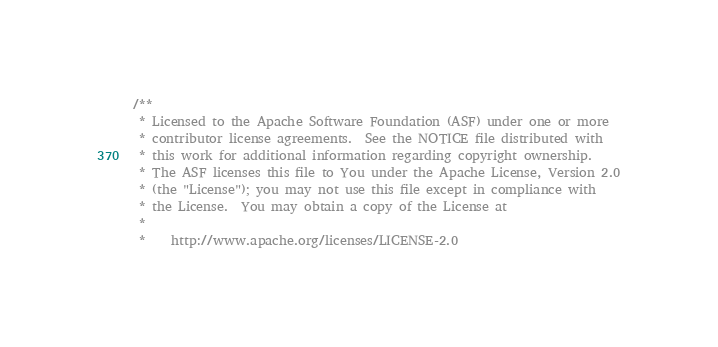<code> <loc_0><loc_0><loc_500><loc_500><_Scala_>/**
 * Licensed to the Apache Software Foundation (ASF) under one or more
 * contributor license agreements.  See the NOTICE file distributed with
 * this work for additional information regarding copyright ownership.
 * The ASF licenses this file to You under the Apache License, Version 2.0
 * (the "License"); you may not use this file except in compliance with
 * the License.  You may obtain a copy of the License at
 * 
 *    http://www.apache.org/licenses/LICENSE-2.0</code> 